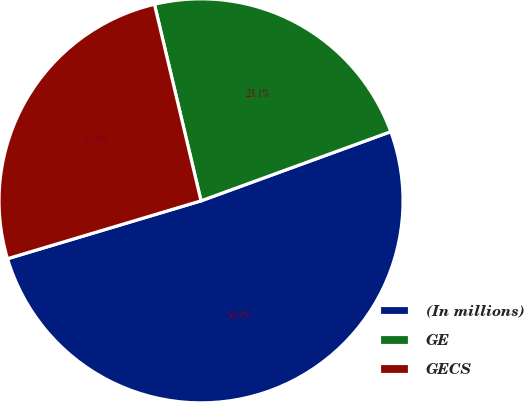Convert chart to OTSL. <chart><loc_0><loc_0><loc_500><loc_500><pie_chart><fcel>(In millions)<fcel>GE<fcel>GECS<nl><fcel>50.94%<fcel>23.14%<fcel>25.92%<nl></chart> 